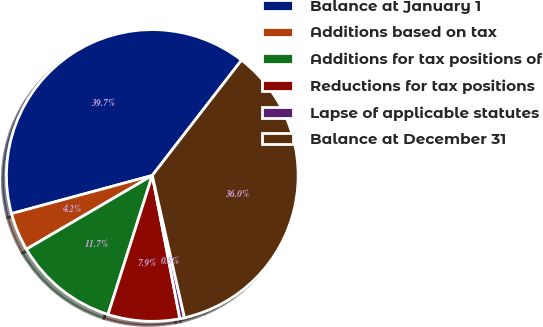Convert chart to OTSL. <chart><loc_0><loc_0><loc_500><loc_500><pie_chart><fcel>Balance at January 1<fcel>Additions based on tax<fcel>Additions for tax positions of<fcel>Reductions for tax positions<fcel>Lapse of applicable statutes<fcel>Balance at December 31<nl><fcel>39.69%<fcel>4.22%<fcel>11.66%<fcel>7.94%<fcel>0.51%<fcel>35.98%<nl></chart> 